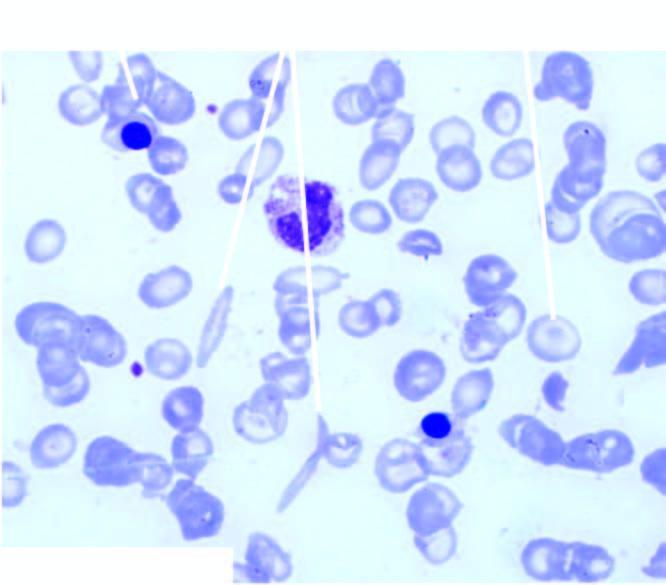what shows crescent shaped elongated red blood cells, a few target cells and a few erythroblasts?
Answer the question using a single word or phrase. Pbf 